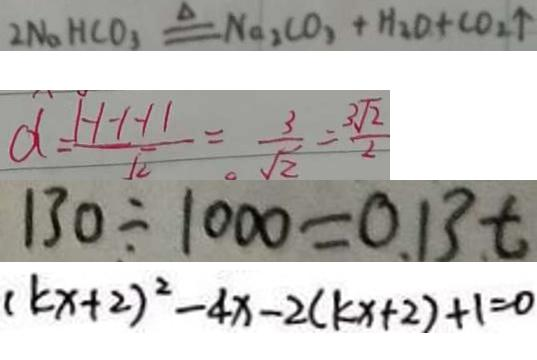<formula> <loc_0><loc_0><loc_500><loc_500>2 N a H C O _ { 3 } \xlongequal { \Delta } N _ { 2 } C O _ { 3 } + H _ { 2 } O + C O _ { 2 } \uparrow 
 d = \frac { 1 - 1 - 1 - 1 1 } { \sqrt { 2 } } = \frac { 3 } { \sqrt { 2 } } = \frac { 3 \sqrt { 2 } } { 2 } 
 1 3 0 \div 1 0 0 0 = 0 . 1 3 t 
 ( k x + 2 ) ^ { 2 } - 4 x - 2 ( k x + 2 ) + 1 = 0</formula> 